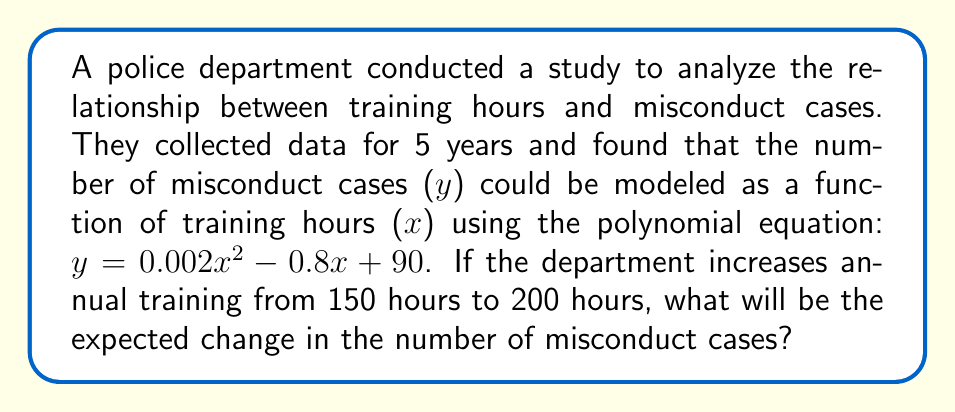Solve this math problem. To solve this problem, we need to:

1. Calculate the number of misconduct cases for 150 training hours
2. Calculate the number of misconduct cases for 200 training hours
3. Find the difference between these two values

Let's go through each step:

1. For 150 training hours:
   $y = 0.002(150)^2 - 0.8(150) + 90$
   $y = 0.002(22500) - 120 + 90$
   $y = 45 - 120 + 90$
   $y = 15$ misconduct cases

2. For 200 training hours:
   $y = 0.002(200)^2 - 0.8(200) + 90$
   $y = 0.002(40000) - 160 + 90$
   $y = 80 - 160 + 90$
   $y = 10$ misconduct cases

3. Change in misconduct cases:
   $\text{Change} = 10 - 15 = -5$ cases

The negative value indicates a decrease in misconduct cases.
Answer: The expected change in the number of misconduct cases is a decrease of 5 cases. 